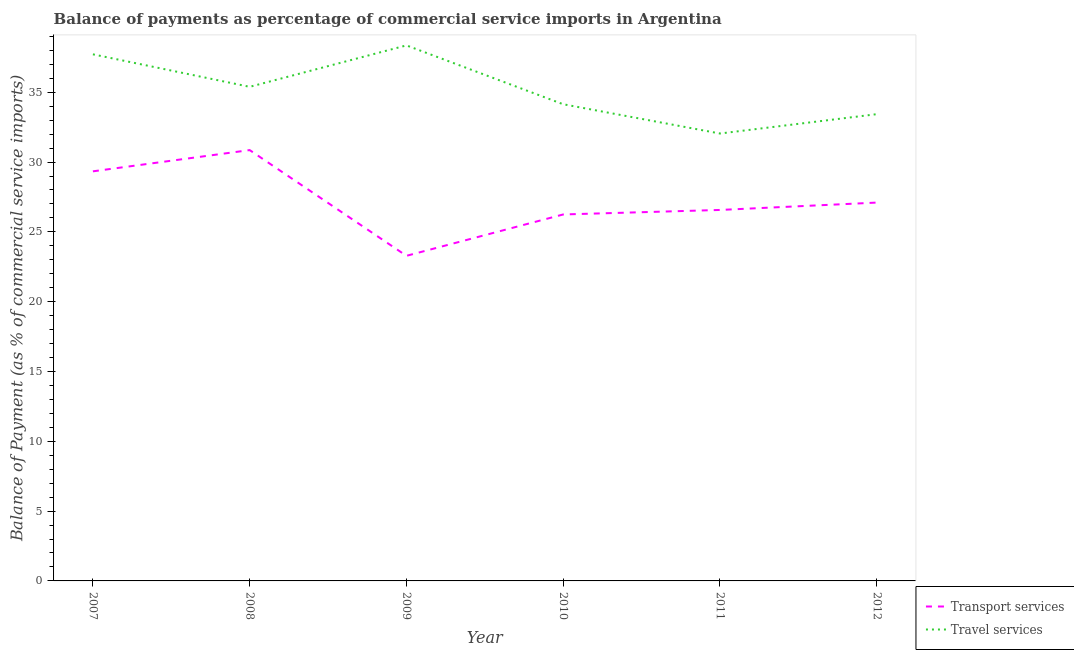Is the number of lines equal to the number of legend labels?
Make the answer very short. Yes. What is the balance of payments of travel services in 2010?
Provide a succinct answer. 34.14. Across all years, what is the maximum balance of payments of travel services?
Your answer should be compact. 38.36. Across all years, what is the minimum balance of payments of travel services?
Offer a very short reply. 32.04. In which year was the balance of payments of transport services maximum?
Your answer should be compact. 2008. What is the total balance of payments of travel services in the graph?
Your answer should be compact. 211.08. What is the difference between the balance of payments of travel services in 2007 and that in 2011?
Offer a terse response. 5.67. What is the difference between the balance of payments of transport services in 2012 and the balance of payments of travel services in 2011?
Provide a succinct answer. -4.95. What is the average balance of payments of travel services per year?
Offer a terse response. 35.18. In the year 2008, what is the difference between the balance of payments of transport services and balance of payments of travel services?
Provide a short and direct response. -4.53. What is the ratio of the balance of payments of travel services in 2008 to that in 2011?
Provide a short and direct response. 1.1. Is the balance of payments of travel services in 2011 less than that in 2012?
Give a very brief answer. Yes. What is the difference between the highest and the second highest balance of payments of travel services?
Provide a short and direct response. 0.64. What is the difference between the highest and the lowest balance of payments of transport services?
Provide a succinct answer. 7.57. Is the sum of the balance of payments of transport services in 2010 and 2012 greater than the maximum balance of payments of travel services across all years?
Make the answer very short. Yes. Is the balance of payments of transport services strictly greater than the balance of payments of travel services over the years?
Provide a succinct answer. No. Is the balance of payments of transport services strictly less than the balance of payments of travel services over the years?
Ensure brevity in your answer.  Yes. How many years are there in the graph?
Give a very brief answer. 6. Are the values on the major ticks of Y-axis written in scientific E-notation?
Your answer should be compact. No. How many legend labels are there?
Your answer should be compact. 2. How are the legend labels stacked?
Your response must be concise. Vertical. What is the title of the graph?
Provide a succinct answer. Balance of payments as percentage of commercial service imports in Argentina. Does "Working only" appear as one of the legend labels in the graph?
Your answer should be compact. No. What is the label or title of the X-axis?
Make the answer very short. Year. What is the label or title of the Y-axis?
Offer a very short reply. Balance of Payment (as % of commercial service imports). What is the Balance of Payment (as % of commercial service imports) of Transport services in 2007?
Keep it short and to the point. 29.34. What is the Balance of Payment (as % of commercial service imports) of Travel services in 2007?
Your answer should be very brief. 37.72. What is the Balance of Payment (as % of commercial service imports) of Transport services in 2008?
Give a very brief answer. 30.86. What is the Balance of Payment (as % of commercial service imports) of Travel services in 2008?
Provide a succinct answer. 35.39. What is the Balance of Payment (as % of commercial service imports) in Transport services in 2009?
Your answer should be very brief. 23.28. What is the Balance of Payment (as % of commercial service imports) of Travel services in 2009?
Provide a succinct answer. 38.36. What is the Balance of Payment (as % of commercial service imports) in Transport services in 2010?
Your answer should be very brief. 26.25. What is the Balance of Payment (as % of commercial service imports) of Travel services in 2010?
Make the answer very short. 34.14. What is the Balance of Payment (as % of commercial service imports) in Transport services in 2011?
Provide a succinct answer. 26.57. What is the Balance of Payment (as % of commercial service imports) in Travel services in 2011?
Provide a succinct answer. 32.04. What is the Balance of Payment (as % of commercial service imports) of Transport services in 2012?
Offer a very short reply. 27.1. What is the Balance of Payment (as % of commercial service imports) of Travel services in 2012?
Offer a very short reply. 33.43. Across all years, what is the maximum Balance of Payment (as % of commercial service imports) in Transport services?
Ensure brevity in your answer.  30.86. Across all years, what is the maximum Balance of Payment (as % of commercial service imports) of Travel services?
Ensure brevity in your answer.  38.36. Across all years, what is the minimum Balance of Payment (as % of commercial service imports) in Transport services?
Give a very brief answer. 23.28. Across all years, what is the minimum Balance of Payment (as % of commercial service imports) in Travel services?
Give a very brief answer. 32.04. What is the total Balance of Payment (as % of commercial service imports) of Transport services in the graph?
Offer a very short reply. 163.39. What is the total Balance of Payment (as % of commercial service imports) in Travel services in the graph?
Your answer should be compact. 211.08. What is the difference between the Balance of Payment (as % of commercial service imports) in Transport services in 2007 and that in 2008?
Make the answer very short. -1.52. What is the difference between the Balance of Payment (as % of commercial service imports) of Travel services in 2007 and that in 2008?
Keep it short and to the point. 2.33. What is the difference between the Balance of Payment (as % of commercial service imports) of Transport services in 2007 and that in 2009?
Keep it short and to the point. 6.05. What is the difference between the Balance of Payment (as % of commercial service imports) in Travel services in 2007 and that in 2009?
Offer a very short reply. -0.64. What is the difference between the Balance of Payment (as % of commercial service imports) of Transport services in 2007 and that in 2010?
Your answer should be very brief. 3.09. What is the difference between the Balance of Payment (as % of commercial service imports) of Travel services in 2007 and that in 2010?
Offer a very short reply. 3.58. What is the difference between the Balance of Payment (as % of commercial service imports) of Transport services in 2007 and that in 2011?
Provide a short and direct response. 2.77. What is the difference between the Balance of Payment (as % of commercial service imports) in Travel services in 2007 and that in 2011?
Keep it short and to the point. 5.67. What is the difference between the Balance of Payment (as % of commercial service imports) of Transport services in 2007 and that in 2012?
Make the answer very short. 2.24. What is the difference between the Balance of Payment (as % of commercial service imports) of Travel services in 2007 and that in 2012?
Offer a terse response. 4.29. What is the difference between the Balance of Payment (as % of commercial service imports) of Transport services in 2008 and that in 2009?
Provide a succinct answer. 7.57. What is the difference between the Balance of Payment (as % of commercial service imports) in Travel services in 2008 and that in 2009?
Keep it short and to the point. -2.97. What is the difference between the Balance of Payment (as % of commercial service imports) in Transport services in 2008 and that in 2010?
Your answer should be very brief. 4.61. What is the difference between the Balance of Payment (as % of commercial service imports) in Travel services in 2008 and that in 2010?
Offer a very short reply. 1.25. What is the difference between the Balance of Payment (as % of commercial service imports) in Transport services in 2008 and that in 2011?
Provide a short and direct response. 4.29. What is the difference between the Balance of Payment (as % of commercial service imports) of Travel services in 2008 and that in 2011?
Ensure brevity in your answer.  3.34. What is the difference between the Balance of Payment (as % of commercial service imports) of Transport services in 2008 and that in 2012?
Your response must be concise. 3.76. What is the difference between the Balance of Payment (as % of commercial service imports) of Travel services in 2008 and that in 2012?
Your answer should be very brief. 1.96. What is the difference between the Balance of Payment (as % of commercial service imports) in Transport services in 2009 and that in 2010?
Provide a short and direct response. -2.96. What is the difference between the Balance of Payment (as % of commercial service imports) in Travel services in 2009 and that in 2010?
Your response must be concise. 4.22. What is the difference between the Balance of Payment (as % of commercial service imports) in Transport services in 2009 and that in 2011?
Give a very brief answer. -3.29. What is the difference between the Balance of Payment (as % of commercial service imports) in Travel services in 2009 and that in 2011?
Make the answer very short. 6.31. What is the difference between the Balance of Payment (as % of commercial service imports) of Transport services in 2009 and that in 2012?
Offer a terse response. -3.81. What is the difference between the Balance of Payment (as % of commercial service imports) in Travel services in 2009 and that in 2012?
Ensure brevity in your answer.  4.93. What is the difference between the Balance of Payment (as % of commercial service imports) in Transport services in 2010 and that in 2011?
Ensure brevity in your answer.  -0.32. What is the difference between the Balance of Payment (as % of commercial service imports) in Travel services in 2010 and that in 2011?
Your response must be concise. 2.1. What is the difference between the Balance of Payment (as % of commercial service imports) of Transport services in 2010 and that in 2012?
Provide a short and direct response. -0.85. What is the difference between the Balance of Payment (as % of commercial service imports) in Travel services in 2010 and that in 2012?
Your response must be concise. 0.71. What is the difference between the Balance of Payment (as % of commercial service imports) of Transport services in 2011 and that in 2012?
Your response must be concise. -0.53. What is the difference between the Balance of Payment (as % of commercial service imports) in Travel services in 2011 and that in 2012?
Your response must be concise. -1.39. What is the difference between the Balance of Payment (as % of commercial service imports) of Transport services in 2007 and the Balance of Payment (as % of commercial service imports) of Travel services in 2008?
Ensure brevity in your answer.  -6.05. What is the difference between the Balance of Payment (as % of commercial service imports) in Transport services in 2007 and the Balance of Payment (as % of commercial service imports) in Travel services in 2009?
Your response must be concise. -9.02. What is the difference between the Balance of Payment (as % of commercial service imports) in Transport services in 2007 and the Balance of Payment (as % of commercial service imports) in Travel services in 2010?
Your response must be concise. -4.8. What is the difference between the Balance of Payment (as % of commercial service imports) of Transport services in 2007 and the Balance of Payment (as % of commercial service imports) of Travel services in 2011?
Your answer should be compact. -2.71. What is the difference between the Balance of Payment (as % of commercial service imports) in Transport services in 2007 and the Balance of Payment (as % of commercial service imports) in Travel services in 2012?
Your answer should be compact. -4.09. What is the difference between the Balance of Payment (as % of commercial service imports) of Transport services in 2008 and the Balance of Payment (as % of commercial service imports) of Travel services in 2009?
Your answer should be very brief. -7.5. What is the difference between the Balance of Payment (as % of commercial service imports) of Transport services in 2008 and the Balance of Payment (as % of commercial service imports) of Travel services in 2010?
Give a very brief answer. -3.28. What is the difference between the Balance of Payment (as % of commercial service imports) in Transport services in 2008 and the Balance of Payment (as % of commercial service imports) in Travel services in 2011?
Provide a succinct answer. -1.19. What is the difference between the Balance of Payment (as % of commercial service imports) in Transport services in 2008 and the Balance of Payment (as % of commercial service imports) in Travel services in 2012?
Give a very brief answer. -2.57. What is the difference between the Balance of Payment (as % of commercial service imports) in Transport services in 2009 and the Balance of Payment (as % of commercial service imports) in Travel services in 2010?
Keep it short and to the point. -10.86. What is the difference between the Balance of Payment (as % of commercial service imports) in Transport services in 2009 and the Balance of Payment (as % of commercial service imports) in Travel services in 2011?
Your answer should be compact. -8.76. What is the difference between the Balance of Payment (as % of commercial service imports) of Transport services in 2009 and the Balance of Payment (as % of commercial service imports) of Travel services in 2012?
Your response must be concise. -10.15. What is the difference between the Balance of Payment (as % of commercial service imports) of Transport services in 2010 and the Balance of Payment (as % of commercial service imports) of Travel services in 2011?
Keep it short and to the point. -5.8. What is the difference between the Balance of Payment (as % of commercial service imports) in Transport services in 2010 and the Balance of Payment (as % of commercial service imports) in Travel services in 2012?
Provide a short and direct response. -7.18. What is the difference between the Balance of Payment (as % of commercial service imports) in Transport services in 2011 and the Balance of Payment (as % of commercial service imports) in Travel services in 2012?
Your answer should be compact. -6.86. What is the average Balance of Payment (as % of commercial service imports) of Transport services per year?
Your response must be concise. 27.23. What is the average Balance of Payment (as % of commercial service imports) of Travel services per year?
Your answer should be very brief. 35.18. In the year 2007, what is the difference between the Balance of Payment (as % of commercial service imports) in Transport services and Balance of Payment (as % of commercial service imports) in Travel services?
Make the answer very short. -8.38. In the year 2008, what is the difference between the Balance of Payment (as % of commercial service imports) of Transport services and Balance of Payment (as % of commercial service imports) of Travel services?
Make the answer very short. -4.53. In the year 2009, what is the difference between the Balance of Payment (as % of commercial service imports) in Transport services and Balance of Payment (as % of commercial service imports) in Travel services?
Provide a succinct answer. -15.07. In the year 2010, what is the difference between the Balance of Payment (as % of commercial service imports) of Transport services and Balance of Payment (as % of commercial service imports) of Travel services?
Your response must be concise. -7.89. In the year 2011, what is the difference between the Balance of Payment (as % of commercial service imports) in Transport services and Balance of Payment (as % of commercial service imports) in Travel services?
Keep it short and to the point. -5.47. In the year 2012, what is the difference between the Balance of Payment (as % of commercial service imports) in Transport services and Balance of Payment (as % of commercial service imports) in Travel services?
Your response must be concise. -6.33. What is the ratio of the Balance of Payment (as % of commercial service imports) of Transport services in 2007 to that in 2008?
Offer a terse response. 0.95. What is the ratio of the Balance of Payment (as % of commercial service imports) of Travel services in 2007 to that in 2008?
Give a very brief answer. 1.07. What is the ratio of the Balance of Payment (as % of commercial service imports) in Transport services in 2007 to that in 2009?
Offer a very short reply. 1.26. What is the ratio of the Balance of Payment (as % of commercial service imports) of Travel services in 2007 to that in 2009?
Provide a succinct answer. 0.98. What is the ratio of the Balance of Payment (as % of commercial service imports) of Transport services in 2007 to that in 2010?
Provide a short and direct response. 1.12. What is the ratio of the Balance of Payment (as % of commercial service imports) of Travel services in 2007 to that in 2010?
Your answer should be compact. 1.1. What is the ratio of the Balance of Payment (as % of commercial service imports) in Transport services in 2007 to that in 2011?
Offer a terse response. 1.1. What is the ratio of the Balance of Payment (as % of commercial service imports) in Travel services in 2007 to that in 2011?
Give a very brief answer. 1.18. What is the ratio of the Balance of Payment (as % of commercial service imports) of Transport services in 2007 to that in 2012?
Keep it short and to the point. 1.08. What is the ratio of the Balance of Payment (as % of commercial service imports) in Travel services in 2007 to that in 2012?
Make the answer very short. 1.13. What is the ratio of the Balance of Payment (as % of commercial service imports) in Transport services in 2008 to that in 2009?
Make the answer very short. 1.33. What is the ratio of the Balance of Payment (as % of commercial service imports) in Travel services in 2008 to that in 2009?
Provide a succinct answer. 0.92. What is the ratio of the Balance of Payment (as % of commercial service imports) in Transport services in 2008 to that in 2010?
Give a very brief answer. 1.18. What is the ratio of the Balance of Payment (as % of commercial service imports) of Travel services in 2008 to that in 2010?
Your answer should be compact. 1.04. What is the ratio of the Balance of Payment (as % of commercial service imports) of Transport services in 2008 to that in 2011?
Keep it short and to the point. 1.16. What is the ratio of the Balance of Payment (as % of commercial service imports) in Travel services in 2008 to that in 2011?
Your answer should be compact. 1.1. What is the ratio of the Balance of Payment (as % of commercial service imports) of Transport services in 2008 to that in 2012?
Make the answer very short. 1.14. What is the ratio of the Balance of Payment (as % of commercial service imports) of Travel services in 2008 to that in 2012?
Your answer should be very brief. 1.06. What is the ratio of the Balance of Payment (as % of commercial service imports) of Transport services in 2009 to that in 2010?
Offer a terse response. 0.89. What is the ratio of the Balance of Payment (as % of commercial service imports) in Travel services in 2009 to that in 2010?
Your answer should be very brief. 1.12. What is the ratio of the Balance of Payment (as % of commercial service imports) of Transport services in 2009 to that in 2011?
Keep it short and to the point. 0.88. What is the ratio of the Balance of Payment (as % of commercial service imports) of Travel services in 2009 to that in 2011?
Your answer should be compact. 1.2. What is the ratio of the Balance of Payment (as % of commercial service imports) in Transport services in 2009 to that in 2012?
Your answer should be very brief. 0.86. What is the ratio of the Balance of Payment (as % of commercial service imports) in Travel services in 2009 to that in 2012?
Your response must be concise. 1.15. What is the ratio of the Balance of Payment (as % of commercial service imports) in Transport services in 2010 to that in 2011?
Provide a short and direct response. 0.99. What is the ratio of the Balance of Payment (as % of commercial service imports) of Travel services in 2010 to that in 2011?
Your answer should be very brief. 1.07. What is the ratio of the Balance of Payment (as % of commercial service imports) of Transport services in 2010 to that in 2012?
Your answer should be compact. 0.97. What is the ratio of the Balance of Payment (as % of commercial service imports) of Travel services in 2010 to that in 2012?
Make the answer very short. 1.02. What is the ratio of the Balance of Payment (as % of commercial service imports) of Transport services in 2011 to that in 2012?
Keep it short and to the point. 0.98. What is the ratio of the Balance of Payment (as % of commercial service imports) in Travel services in 2011 to that in 2012?
Your answer should be very brief. 0.96. What is the difference between the highest and the second highest Balance of Payment (as % of commercial service imports) in Transport services?
Offer a very short reply. 1.52. What is the difference between the highest and the second highest Balance of Payment (as % of commercial service imports) in Travel services?
Offer a terse response. 0.64. What is the difference between the highest and the lowest Balance of Payment (as % of commercial service imports) of Transport services?
Your answer should be compact. 7.57. What is the difference between the highest and the lowest Balance of Payment (as % of commercial service imports) in Travel services?
Your answer should be compact. 6.31. 